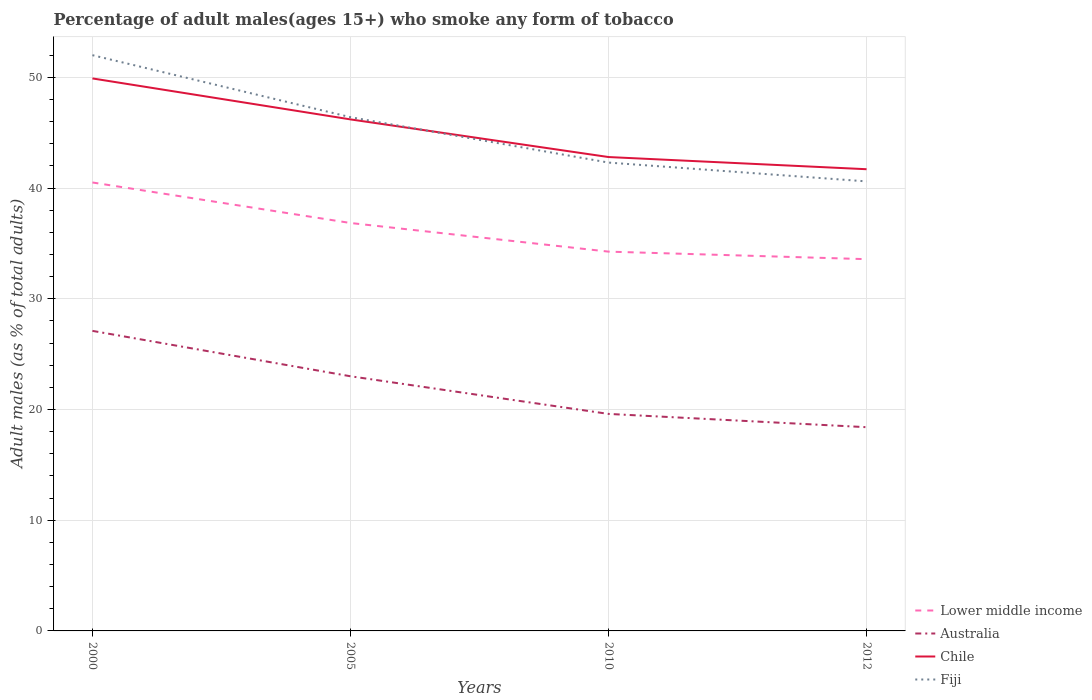How many different coloured lines are there?
Your answer should be compact. 4. Does the line corresponding to Lower middle income intersect with the line corresponding to Chile?
Keep it short and to the point. No. Is the number of lines equal to the number of legend labels?
Your answer should be compact. Yes. Across all years, what is the maximum percentage of adult males who smoke in Chile?
Your response must be concise. 41.7. In which year was the percentage of adult males who smoke in Fiji maximum?
Provide a succinct answer. 2012. What is the total percentage of adult males who smoke in Fiji in the graph?
Keep it short and to the point. 9.7. What is the difference between the highest and the second highest percentage of adult males who smoke in Lower middle income?
Your answer should be very brief. 6.93. Is the percentage of adult males who smoke in Chile strictly greater than the percentage of adult males who smoke in Lower middle income over the years?
Offer a very short reply. No. How many years are there in the graph?
Provide a short and direct response. 4. What is the difference between two consecutive major ticks on the Y-axis?
Give a very brief answer. 10. Are the values on the major ticks of Y-axis written in scientific E-notation?
Provide a short and direct response. No. Where does the legend appear in the graph?
Keep it short and to the point. Bottom right. How are the legend labels stacked?
Your answer should be compact. Vertical. What is the title of the graph?
Make the answer very short. Percentage of adult males(ages 15+) who smoke any form of tobacco. Does "Eritrea" appear as one of the legend labels in the graph?
Provide a short and direct response. No. What is the label or title of the Y-axis?
Your answer should be very brief. Adult males (as % of total adults). What is the Adult males (as % of total adults) in Lower middle income in 2000?
Offer a very short reply. 40.5. What is the Adult males (as % of total adults) of Australia in 2000?
Keep it short and to the point. 27.1. What is the Adult males (as % of total adults) in Chile in 2000?
Give a very brief answer. 49.9. What is the Adult males (as % of total adults) in Fiji in 2000?
Offer a very short reply. 52. What is the Adult males (as % of total adults) in Lower middle income in 2005?
Your response must be concise. 36.84. What is the Adult males (as % of total adults) in Australia in 2005?
Your answer should be very brief. 23. What is the Adult males (as % of total adults) in Chile in 2005?
Keep it short and to the point. 46.2. What is the Adult males (as % of total adults) of Fiji in 2005?
Your answer should be very brief. 46.4. What is the Adult males (as % of total adults) of Lower middle income in 2010?
Offer a very short reply. 34.26. What is the Adult males (as % of total adults) of Australia in 2010?
Ensure brevity in your answer.  19.6. What is the Adult males (as % of total adults) of Chile in 2010?
Provide a short and direct response. 42.8. What is the Adult males (as % of total adults) in Fiji in 2010?
Make the answer very short. 42.3. What is the Adult males (as % of total adults) in Lower middle income in 2012?
Ensure brevity in your answer.  33.58. What is the Adult males (as % of total adults) of Chile in 2012?
Your response must be concise. 41.7. What is the Adult males (as % of total adults) in Fiji in 2012?
Ensure brevity in your answer.  40.6. Across all years, what is the maximum Adult males (as % of total adults) of Lower middle income?
Keep it short and to the point. 40.5. Across all years, what is the maximum Adult males (as % of total adults) of Australia?
Provide a succinct answer. 27.1. Across all years, what is the maximum Adult males (as % of total adults) in Chile?
Offer a terse response. 49.9. Across all years, what is the minimum Adult males (as % of total adults) in Lower middle income?
Make the answer very short. 33.58. Across all years, what is the minimum Adult males (as % of total adults) of Chile?
Ensure brevity in your answer.  41.7. Across all years, what is the minimum Adult males (as % of total adults) in Fiji?
Your response must be concise. 40.6. What is the total Adult males (as % of total adults) of Lower middle income in the graph?
Give a very brief answer. 145.18. What is the total Adult males (as % of total adults) of Australia in the graph?
Offer a very short reply. 88.1. What is the total Adult males (as % of total adults) in Chile in the graph?
Provide a succinct answer. 180.6. What is the total Adult males (as % of total adults) in Fiji in the graph?
Make the answer very short. 181.3. What is the difference between the Adult males (as % of total adults) of Lower middle income in 2000 and that in 2005?
Provide a short and direct response. 3.66. What is the difference between the Adult males (as % of total adults) in Chile in 2000 and that in 2005?
Your response must be concise. 3.7. What is the difference between the Adult males (as % of total adults) of Fiji in 2000 and that in 2005?
Offer a very short reply. 5.6. What is the difference between the Adult males (as % of total adults) of Lower middle income in 2000 and that in 2010?
Provide a succinct answer. 6.25. What is the difference between the Adult males (as % of total adults) in Australia in 2000 and that in 2010?
Keep it short and to the point. 7.5. What is the difference between the Adult males (as % of total adults) in Chile in 2000 and that in 2010?
Your answer should be very brief. 7.1. What is the difference between the Adult males (as % of total adults) in Lower middle income in 2000 and that in 2012?
Your response must be concise. 6.93. What is the difference between the Adult males (as % of total adults) of Lower middle income in 2005 and that in 2010?
Provide a succinct answer. 2.59. What is the difference between the Adult males (as % of total adults) in Australia in 2005 and that in 2010?
Your answer should be very brief. 3.4. What is the difference between the Adult males (as % of total adults) in Fiji in 2005 and that in 2010?
Your answer should be very brief. 4.1. What is the difference between the Adult males (as % of total adults) in Lower middle income in 2005 and that in 2012?
Ensure brevity in your answer.  3.27. What is the difference between the Adult males (as % of total adults) of Lower middle income in 2010 and that in 2012?
Make the answer very short. 0.68. What is the difference between the Adult males (as % of total adults) of Australia in 2010 and that in 2012?
Provide a short and direct response. 1.2. What is the difference between the Adult males (as % of total adults) of Chile in 2010 and that in 2012?
Keep it short and to the point. 1.1. What is the difference between the Adult males (as % of total adults) in Fiji in 2010 and that in 2012?
Your answer should be very brief. 1.7. What is the difference between the Adult males (as % of total adults) of Lower middle income in 2000 and the Adult males (as % of total adults) of Australia in 2005?
Provide a succinct answer. 17.5. What is the difference between the Adult males (as % of total adults) of Lower middle income in 2000 and the Adult males (as % of total adults) of Chile in 2005?
Make the answer very short. -5.7. What is the difference between the Adult males (as % of total adults) in Lower middle income in 2000 and the Adult males (as % of total adults) in Fiji in 2005?
Keep it short and to the point. -5.9. What is the difference between the Adult males (as % of total adults) of Australia in 2000 and the Adult males (as % of total adults) of Chile in 2005?
Offer a terse response. -19.1. What is the difference between the Adult males (as % of total adults) of Australia in 2000 and the Adult males (as % of total adults) of Fiji in 2005?
Offer a terse response. -19.3. What is the difference between the Adult males (as % of total adults) in Chile in 2000 and the Adult males (as % of total adults) in Fiji in 2005?
Ensure brevity in your answer.  3.5. What is the difference between the Adult males (as % of total adults) in Lower middle income in 2000 and the Adult males (as % of total adults) in Australia in 2010?
Offer a very short reply. 20.9. What is the difference between the Adult males (as % of total adults) in Lower middle income in 2000 and the Adult males (as % of total adults) in Chile in 2010?
Give a very brief answer. -2.3. What is the difference between the Adult males (as % of total adults) of Lower middle income in 2000 and the Adult males (as % of total adults) of Fiji in 2010?
Your answer should be compact. -1.8. What is the difference between the Adult males (as % of total adults) in Australia in 2000 and the Adult males (as % of total adults) in Chile in 2010?
Make the answer very short. -15.7. What is the difference between the Adult males (as % of total adults) in Australia in 2000 and the Adult males (as % of total adults) in Fiji in 2010?
Your answer should be compact. -15.2. What is the difference between the Adult males (as % of total adults) in Lower middle income in 2000 and the Adult males (as % of total adults) in Australia in 2012?
Offer a terse response. 22.1. What is the difference between the Adult males (as % of total adults) of Lower middle income in 2000 and the Adult males (as % of total adults) of Chile in 2012?
Offer a very short reply. -1.2. What is the difference between the Adult males (as % of total adults) of Lower middle income in 2000 and the Adult males (as % of total adults) of Fiji in 2012?
Your answer should be very brief. -0.1. What is the difference between the Adult males (as % of total adults) of Australia in 2000 and the Adult males (as % of total adults) of Chile in 2012?
Your answer should be compact. -14.6. What is the difference between the Adult males (as % of total adults) of Lower middle income in 2005 and the Adult males (as % of total adults) of Australia in 2010?
Your answer should be very brief. 17.24. What is the difference between the Adult males (as % of total adults) in Lower middle income in 2005 and the Adult males (as % of total adults) in Chile in 2010?
Provide a short and direct response. -5.96. What is the difference between the Adult males (as % of total adults) of Lower middle income in 2005 and the Adult males (as % of total adults) of Fiji in 2010?
Make the answer very short. -5.46. What is the difference between the Adult males (as % of total adults) of Australia in 2005 and the Adult males (as % of total adults) of Chile in 2010?
Your response must be concise. -19.8. What is the difference between the Adult males (as % of total adults) of Australia in 2005 and the Adult males (as % of total adults) of Fiji in 2010?
Offer a terse response. -19.3. What is the difference between the Adult males (as % of total adults) in Lower middle income in 2005 and the Adult males (as % of total adults) in Australia in 2012?
Offer a very short reply. 18.44. What is the difference between the Adult males (as % of total adults) of Lower middle income in 2005 and the Adult males (as % of total adults) of Chile in 2012?
Offer a very short reply. -4.86. What is the difference between the Adult males (as % of total adults) of Lower middle income in 2005 and the Adult males (as % of total adults) of Fiji in 2012?
Offer a terse response. -3.76. What is the difference between the Adult males (as % of total adults) of Australia in 2005 and the Adult males (as % of total adults) of Chile in 2012?
Your answer should be compact. -18.7. What is the difference between the Adult males (as % of total adults) in Australia in 2005 and the Adult males (as % of total adults) in Fiji in 2012?
Provide a succinct answer. -17.6. What is the difference between the Adult males (as % of total adults) in Chile in 2005 and the Adult males (as % of total adults) in Fiji in 2012?
Offer a very short reply. 5.6. What is the difference between the Adult males (as % of total adults) of Lower middle income in 2010 and the Adult males (as % of total adults) of Australia in 2012?
Provide a short and direct response. 15.86. What is the difference between the Adult males (as % of total adults) of Lower middle income in 2010 and the Adult males (as % of total adults) of Chile in 2012?
Offer a terse response. -7.44. What is the difference between the Adult males (as % of total adults) in Lower middle income in 2010 and the Adult males (as % of total adults) in Fiji in 2012?
Offer a very short reply. -6.34. What is the difference between the Adult males (as % of total adults) of Australia in 2010 and the Adult males (as % of total adults) of Chile in 2012?
Provide a succinct answer. -22.1. What is the difference between the Adult males (as % of total adults) of Australia in 2010 and the Adult males (as % of total adults) of Fiji in 2012?
Offer a terse response. -21. What is the difference between the Adult males (as % of total adults) in Chile in 2010 and the Adult males (as % of total adults) in Fiji in 2012?
Keep it short and to the point. 2.2. What is the average Adult males (as % of total adults) in Lower middle income per year?
Give a very brief answer. 36.29. What is the average Adult males (as % of total adults) of Australia per year?
Ensure brevity in your answer.  22.02. What is the average Adult males (as % of total adults) in Chile per year?
Your answer should be very brief. 45.15. What is the average Adult males (as % of total adults) of Fiji per year?
Offer a very short reply. 45.33. In the year 2000, what is the difference between the Adult males (as % of total adults) of Lower middle income and Adult males (as % of total adults) of Australia?
Keep it short and to the point. 13.4. In the year 2000, what is the difference between the Adult males (as % of total adults) of Lower middle income and Adult males (as % of total adults) of Chile?
Ensure brevity in your answer.  -9.4. In the year 2000, what is the difference between the Adult males (as % of total adults) of Lower middle income and Adult males (as % of total adults) of Fiji?
Provide a succinct answer. -11.5. In the year 2000, what is the difference between the Adult males (as % of total adults) in Australia and Adult males (as % of total adults) in Chile?
Your answer should be very brief. -22.8. In the year 2000, what is the difference between the Adult males (as % of total adults) of Australia and Adult males (as % of total adults) of Fiji?
Provide a short and direct response. -24.9. In the year 2000, what is the difference between the Adult males (as % of total adults) in Chile and Adult males (as % of total adults) in Fiji?
Make the answer very short. -2.1. In the year 2005, what is the difference between the Adult males (as % of total adults) of Lower middle income and Adult males (as % of total adults) of Australia?
Provide a succinct answer. 13.84. In the year 2005, what is the difference between the Adult males (as % of total adults) of Lower middle income and Adult males (as % of total adults) of Chile?
Your response must be concise. -9.36. In the year 2005, what is the difference between the Adult males (as % of total adults) in Lower middle income and Adult males (as % of total adults) in Fiji?
Make the answer very short. -9.56. In the year 2005, what is the difference between the Adult males (as % of total adults) of Australia and Adult males (as % of total adults) of Chile?
Keep it short and to the point. -23.2. In the year 2005, what is the difference between the Adult males (as % of total adults) in Australia and Adult males (as % of total adults) in Fiji?
Offer a terse response. -23.4. In the year 2010, what is the difference between the Adult males (as % of total adults) of Lower middle income and Adult males (as % of total adults) of Australia?
Offer a terse response. 14.66. In the year 2010, what is the difference between the Adult males (as % of total adults) in Lower middle income and Adult males (as % of total adults) in Chile?
Your answer should be very brief. -8.54. In the year 2010, what is the difference between the Adult males (as % of total adults) of Lower middle income and Adult males (as % of total adults) of Fiji?
Offer a terse response. -8.04. In the year 2010, what is the difference between the Adult males (as % of total adults) of Australia and Adult males (as % of total adults) of Chile?
Offer a terse response. -23.2. In the year 2010, what is the difference between the Adult males (as % of total adults) of Australia and Adult males (as % of total adults) of Fiji?
Provide a short and direct response. -22.7. In the year 2010, what is the difference between the Adult males (as % of total adults) of Chile and Adult males (as % of total adults) of Fiji?
Ensure brevity in your answer.  0.5. In the year 2012, what is the difference between the Adult males (as % of total adults) in Lower middle income and Adult males (as % of total adults) in Australia?
Provide a succinct answer. 15.18. In the year 2012, what is the difference between the Adult males (as % of total adults) in Lower middle income and Adult males (as % of total adults) in Chile?
Provide a short and direct response. -8.12. In the year 2012, what is the difference between the Adult males (as % of total adults) in Lower middle income and Adult males (as % of total adults) in Fiji?
Keep it short and to the point. -7.02. In the year 2012, what is the difference between the Adult males (as % of total adults) in Australia and Adult males (as % of total adults) in Chile?
Provide a succinct answer. -23.3. In the year 2012, what is the difference between the Adult males (as % of total adults) of Australia and Adult males (as % of total adults) of Fiji?
Provide a succinct answer. -22.2. What is the ratio of the Adult males (as % of total adults) of Lower middle income in 2000 to that in 2005?
Provide a succinct answer. 1.1. What is the ratio of the Adult males (as % of total adults) in Australia in 2000 to that in 2005?
Make the answer very short. 1.18. What is the ratio of the Adult males (as % of total adults) in Chile in 2000 to that in 2005?
Give a very brief answer. 1.08. What is the ratio of the Adult males (as % of total adults) of Fiji in 2000 to that in 2005?
Offer a terse response. 1.12. What is the ratio of the Adult males (as % of total adults) in Lower middle income in 2000 to that in 2010?
Offer a very short reply. 1.18. What is the ratio of the Adult males (as % of total adults) of Australia in 2000 to that in 2010?
Ensure brevity in your answer.  1.38. What is the ratio of the Adult males (as % of total adults) in Chile in 2000 to that in 2010?
Give a very brief answer. 1.17. What is the ratio of the Adult males (as % of total adults) of Fiji in 2000 to that in 2010?
Provide a short and direct response. 1.23. What is the ratio of the Adult males (as % of total adults) in Lower middle income in 2000 to that in 2012?
Your answer should be very brief. 1.21. What is the ratio of the Adult males (as % of total adults) in Australia in 2000 to that in 2012?
Provide a succinct answer. 1.47. What is the ratio of the Adult males (as % of total adults) in Chile in 2000 to that in 2012?
Ensure brevity in your answer.  1.2. What is the ratio of the Adult males (as % of total adults) of Fiji in 2000 to that in 2012?
Provide a short and direct response. 1.28. What is the ratio of the Adult males (as % of total adults) in Lower middle income in 2005 to that in 2010?
Keep it short and to the point. 1.08. What is the ratio of the Adult males (as % of total adults) of Australia in 2005 to that in 2010?
Offer a terse response. 1.17. What is the ratio of the Adult males (as % of total adults) of Chile in 2005 to that in 2010?
Provide a short and direct response. 1.08. What is the ratio of the Adult males (as % of total adults) in Fiji in 2005 to that in 2010?
Offer a terse response. 1.1. What is the ratio of the Adult males (as % of total adults) in Lower middle income in 2005 to that in 2012?
Give a very brief answer. 1.1. What is the ratio of the Adult males (as % of total adults) of Australia in 2005 to that in 2012?
Provide a short and direct response. 1.25. What is the ratio of the Adult males (as % of total adults) of Chile in 2005 to that in 2012?
Provide a short and direct response. 1.11. What is the ratio of the Adult males (as % of total adults) in Fiji in 2005 to that in 2012?
Provide a succinct answer. 1.14. What is the ratio of the Adult males (as % of total adults) in Lower middle income in 2010 to that in 2012?
Your answer should be very brief. 1.02. What is the ratio of the Adult males (as % of total adults) in Australia in 2010 to that in 2012?
Provide a short and direct response. 1.07. What is the ratio of the Adult males (as % of total adults) of Chile in 2010 to that in 2012?
Your answer should be very brief. 1.03. What is the ratio of the Adult males (as % of total adults) of Fiji in 2010 to that in 2012?
Make the answer very short. 1.04. What is the difference between the highest and the second highest Adult males (as % of total adults) in Lower middle income?
Make the answer very short. 3.66. What is the difference between the highest and the second highest Adult males (as % of total adults) of Australia?
Ensure brevity in your answer.  4.1. What is the difference between the highest and the lowest Adult males (as % of total adults) of Lower middle income?
Offer a very short reply. 6.93. What is the difference between the highest and the lowest Adult males (as % of total adults) in Chile?
Make the answer very short. 8.2. 